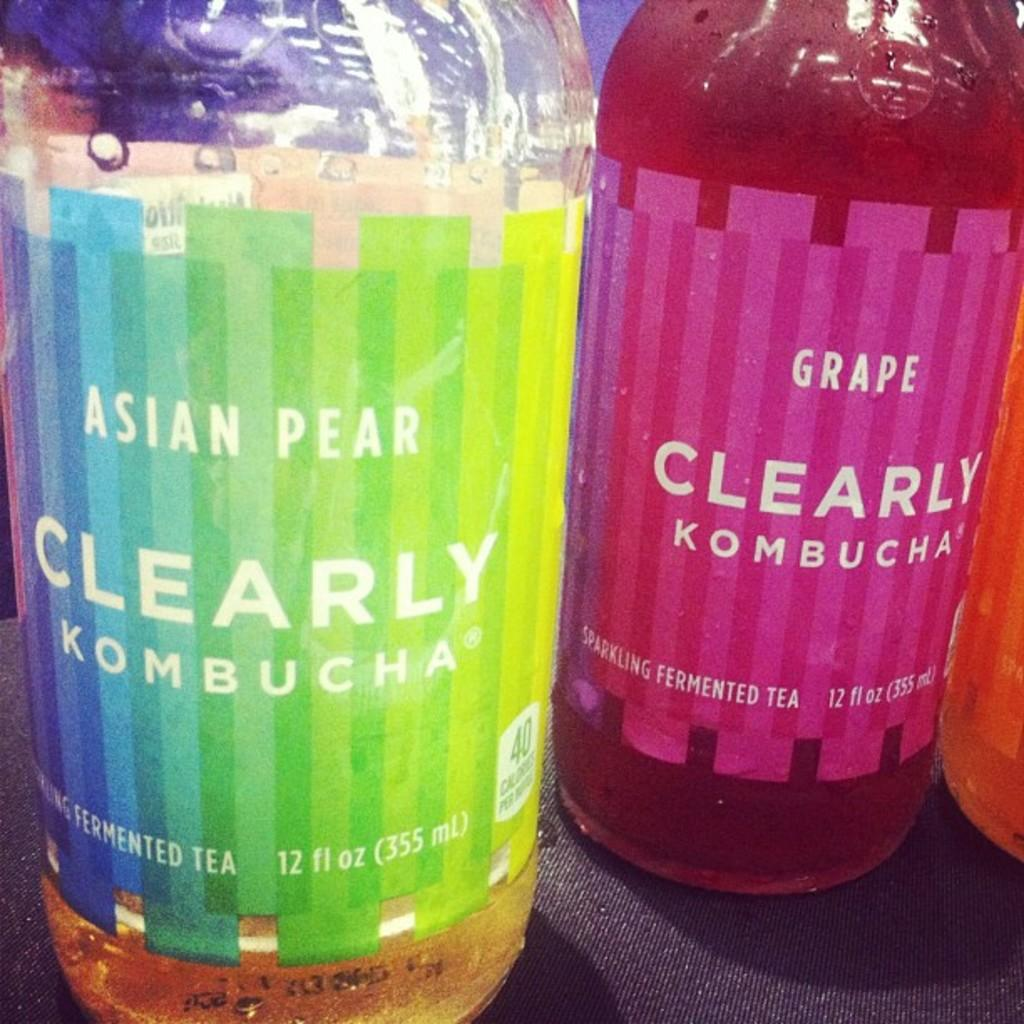<image>
Share a concise interpretation of the image provided. Two bottles of kombucha are adjacent to each other 